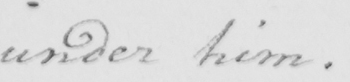What does this handwritten line say? under him . 